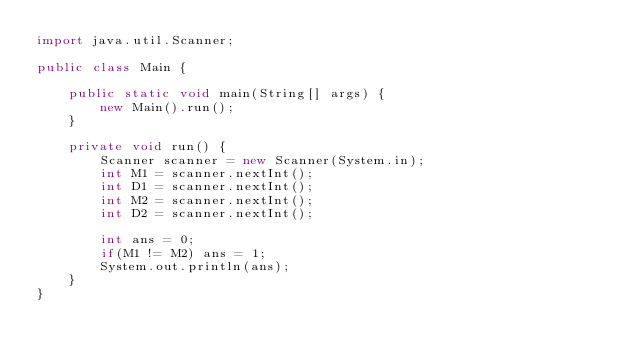<code> <loc_0><loc_0><loc_500><loc_500><_Java_>import java.util.Scanner;

public class Main {

    public static void main(String[] args) {
        new Main().run();
    }

    private void run() {
        Scanner scanner = new Scanner(System.in);
        int M1 = scanner.nextInt();
        int D1 = scanner.nextInt();
        int M2 = scanner.nextInt();
        int D2 = scanner.nextInt();

        int ans = 0;
        if(M1 != M2) ans = 1;
        System.out.println(ans);
    }
}</code> 